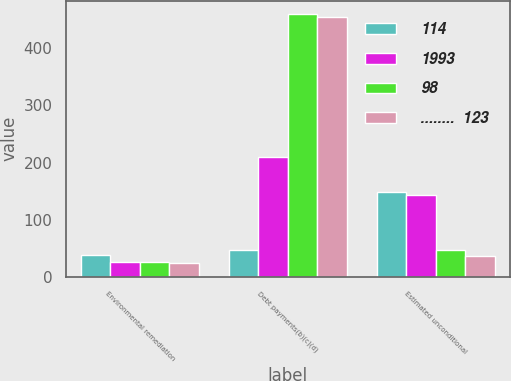<chart> <loc_0><loc_0><loc_500><loc_500><stacked_bar_chart><ecel><fcel>Environmental remediation<fcel>Debt payments(b)(c)(d)<fcel>Estimated unconditional<nl><fcel>114<fcel>38<fcel>47<fcel>148<nl><fcel>1993<fcel>26<fcel>210<fcel>143<nl><fcel>98<fcel>27<fcel>460<fcel>47<nl><fcel>........  123<fcel>24<fcel>455<fcel>36<nl></chart> 